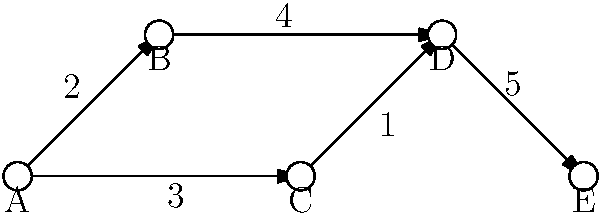In the network diagram representing communication channels, what is the optimal path from node A to node E that maximizes the total weight (representing communication efficiency)? Additionally, calculate the efficiency ratio of the optimal path compared to the least efficient path. To solve this problem, we need to follow these steps:

1. Identify all possible paths from A to E:
   - Path 1: A → B → D → E
   - Path 2: A → C → D → E

2. Calculate the total weight for each path:
   - Path 1: A → B (2) + B → D (4) + D → E (5) = 11
   - Path 2: A → C (3) + C → D (1) + D → E (5) = 9

3. Determine the optimal path:
   The optimal path is the one with the maximum total weight, which is Path 1 (A → B → D → E) with a total weight of 11.

4. Identify the least efficient path:
   The least efficient path is Path 2 (A → C → D → E) with a total weight of 9.

5. Calculate the efficiency ratio:
   Efficiency ratio = (Optimal path weight) / (Least efficient path weight)
   $$\text{Efficiency ratio} = \frac{11}{9} \approx 1.22$$

Thus, the optimal path is 22% more efficient than the least efficient path.
Answer: Optimal path: A → B → D → E; Efficiency ratio: $\frac{11}{9}$ or approximately 1.22 